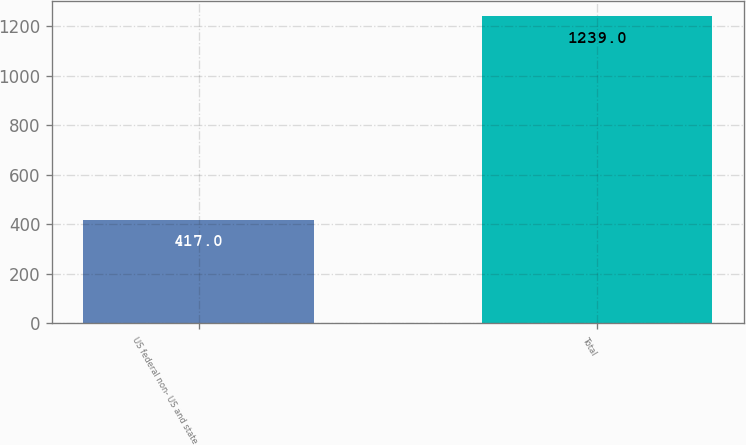Convert chart. <chart><loc_0><loc_0><loc_500><loc_500><bar_chart><fcel>US federal non- US and state<fcel>Total<nl><fcel>417<fcel>1239<nl></chart> 